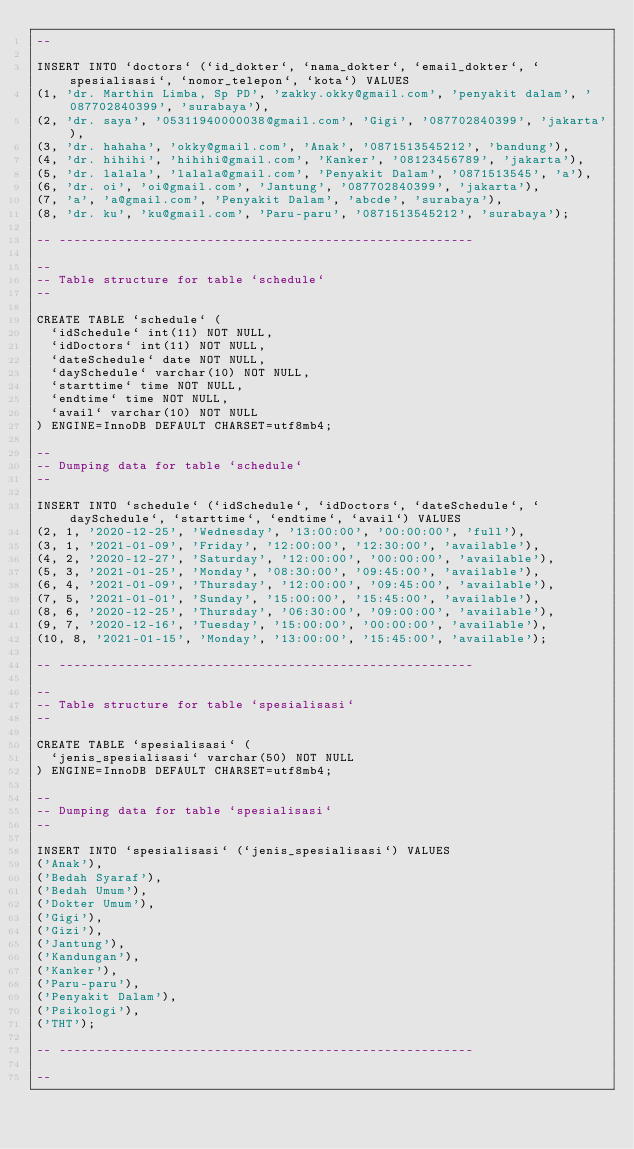Convert code to text. <code><loc_0><loc_0><loc_500><loc_500><_SQL_>--

INSERT INTO `doctors` (`id_dokter`, `nama_dokter`, `email_dokter`, `spesialisasi`, `nomor_telepon`, `kota`) VALUES
(1, 'dr. Marthin Limba, Sp PD', 'zakky.okky@gmail.com', 'penyakit dalam', '087702840399', 'surabaya'),
(2, 'dr. saya', '05311940000038@gmail.com', 'Gigi', '087702840399', 'jakarta'),
(3, 'dr. hahaha', 'okky@gmail.com', 'Anak', '0871513545212', 'bandung'),
(4, 'dr. hihihi', 'hihihi@gmail.com', 'Kanker', '08123456789', 'jakarta'),
(5, 'dr. lalala', 'lalala@gmail.com', 'Penyakit Dalam', '0871513545', 'a'),
(6, 'dr. oi', 'oi@gmail.com', 'Jantung', '087702840399', 'jakarta'),
(7, 'a', 'a@gmail.com', 'Penyakit Dalam', 'abcde', 'surabaya'),
(8, 'dr. ku', 'ku@gmail.com', 'Paru-paru', '0871513545212', 'surabaya');

-- --------------------------------------------------------

--
-- Table structure for table `schedule`
--

CREATE TABLE `schedule` (
  `idSchedule` int(11) NOT NULL,
  `idDoctors` int(11) NOT NULL,
  `dateSchedule` date NOT NULL,
  `daySchedule` varchar(10) NOT NULL,
  `starttime` time NOT NULL,
  `endtime` time NOT NULL,
  `avail` varchar(10) NOT NULL
) ENGINE=InnoDB DEFAULT CHARSET=utf8mb4;

--
-- Dumping data for table `schedule`
--

INSERT INTO `schedule` (`idSchedule`, `idDoctors`, `dateSchedule`, `daySchedule`, `starttime`, `endtime`, `avail`) VALUES
(2, 1, '2020-12-25', 'Wednesday', '13:00:00', '00:00:00', 'full'),
(3, 1, '2021-01-09', 'Friday', '12:00:00', '12:30:00', 'available'),
(4, 2, '2020-12-27', 'Saturday', '12:00:00', '00:00:00', 'available'),
(5, 3, '2021-01-25', 'Monday', '08:30:00', '09:45:00', 'available'),
(6, 4, '2021-01-09', 'Thursday', '12:00:00', '09:45:00', 'available'),
(7, 5, '2021-01-01', 'Sunday', '15:00:00', '15:45:00', 'available'),
(8, 6, '2020-12-25', 'Thursday', '06:30:00', '09:00:00', 'available'),
(9, 7, '2020-12-16', 'Tuesday', '15:00:00', '00:00:00', 'available'),
(10, 8, '2021-01-15', 'Monday', '13:00:00', '15:45:00', 'available');

-- --------------------------------------------------------

--
-- Table structure for table `spesialisasi`
--

CREATE TABLE `spesialisasi` (
  `jenis_spesialisasi` varchar(50) NOT NULL
) ENGINE=InnoDB DEFAULT CHARSET=utf8mb4;

--
-- Dumping data for table `spesialisasi`
--

INSERT INTO `spesialisasi` (`jenis_spesialisasi`) VALUES
('Anak'),
('Bedah Syaraf'),
('Bedah Umum'),
('Dokter Umum'),
('Gigi'),
('Gizi'),
('Jantung'),
('Kandungan'),
('Kanker'),
('Paru-paru'),
('Penyakit Dalam'),
('Psikologi'),
('THT');

-- --------------------------------------------------------

--</code> 